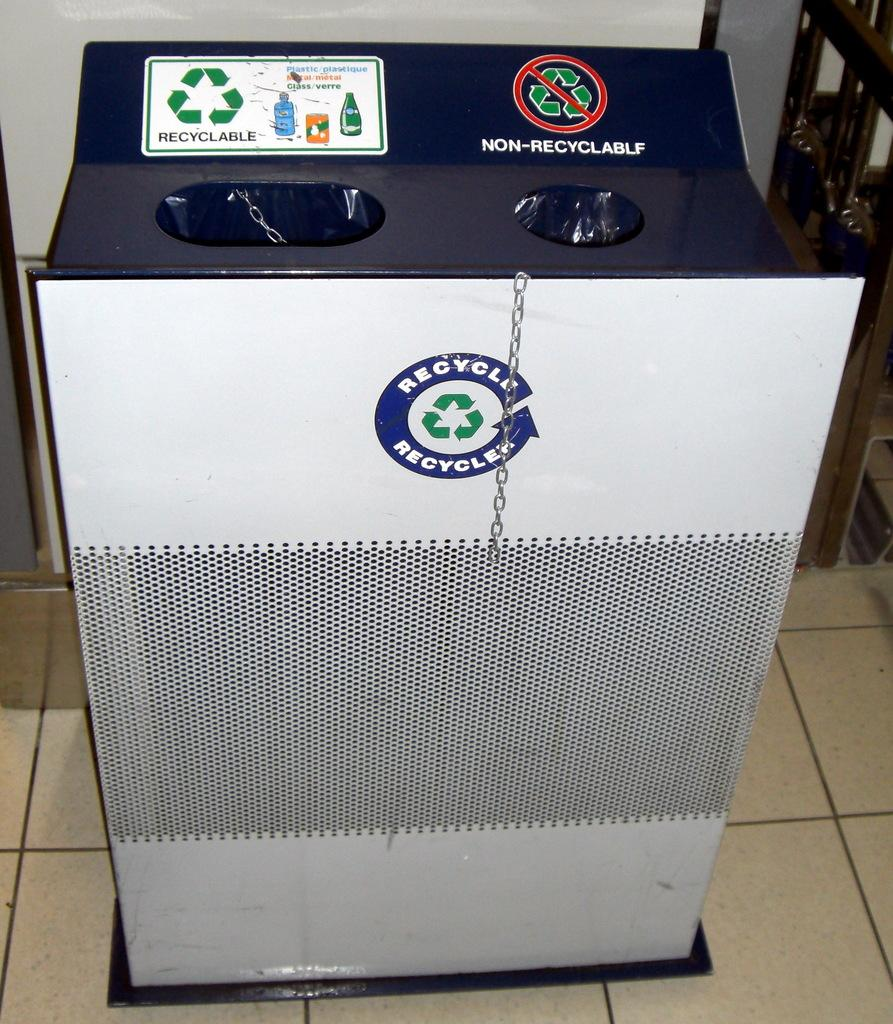What is the main subject of the image? The main subject of the image is a machine. Can you describe the color of the machine? The machine has a white and blue color. What can be seen in the background of the image? The background of the image includes a white wall. How many chairs are placed around the machine in the image? There are no chairs present in the image; it only features a machine with a white and blue color against a white wall background. 